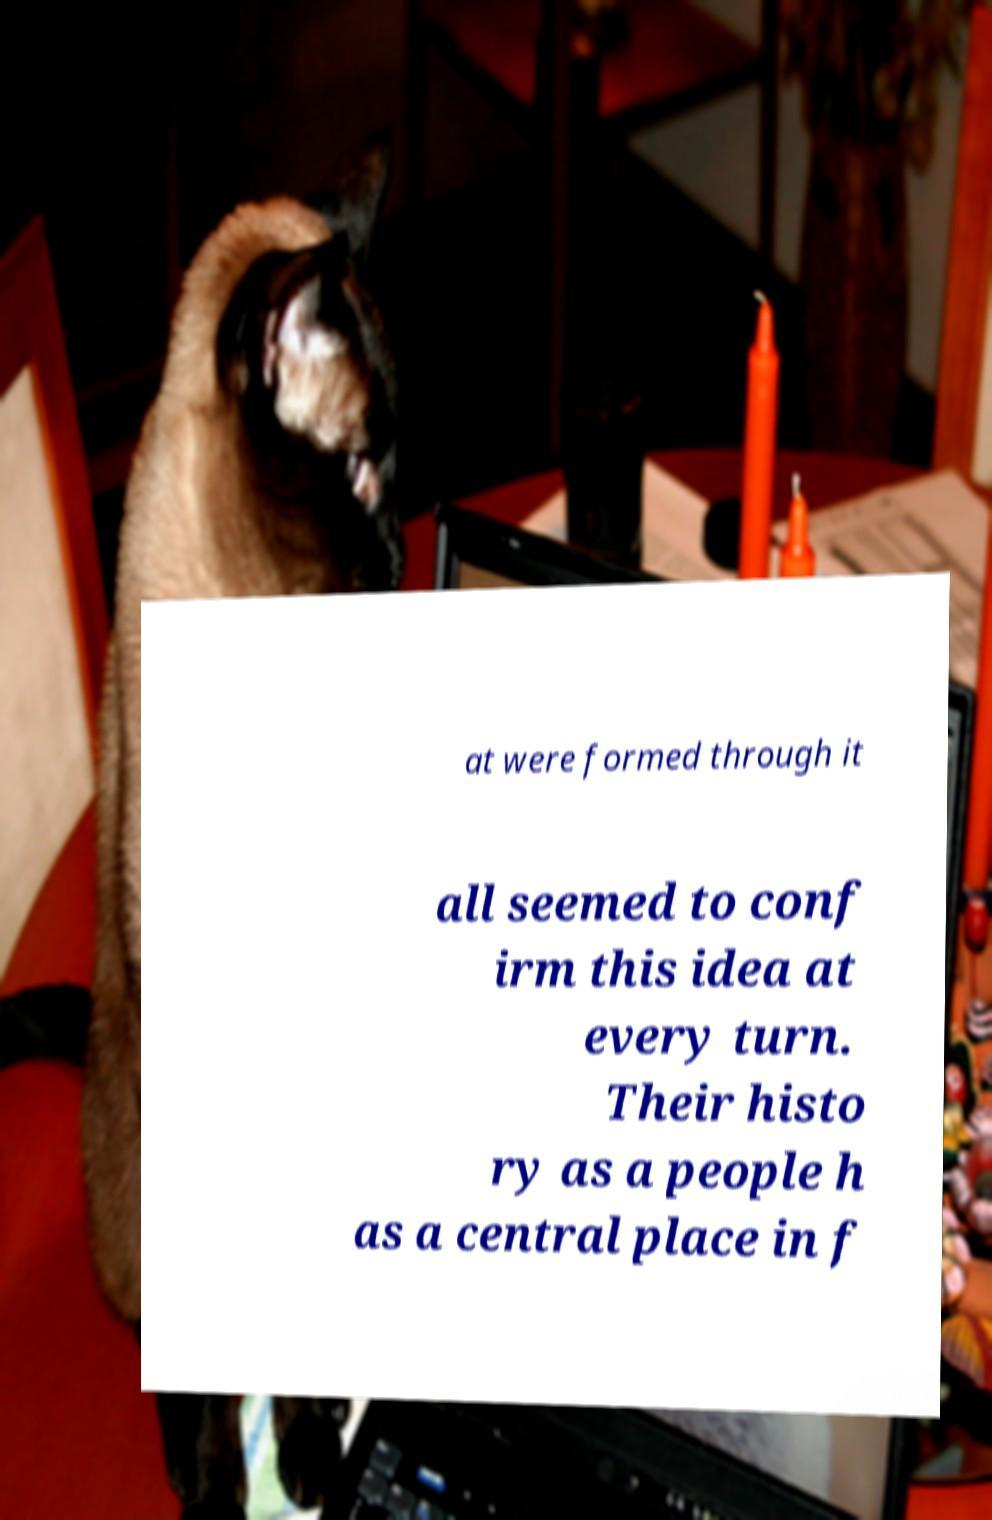Can you read and provide the text displayed in the image?This photo seems to have some interesting text. Can you extract and type it out for me? at were formed through it all seemed to conf irm this idea at every turn. Their histo ry as a people h as a central place in f 